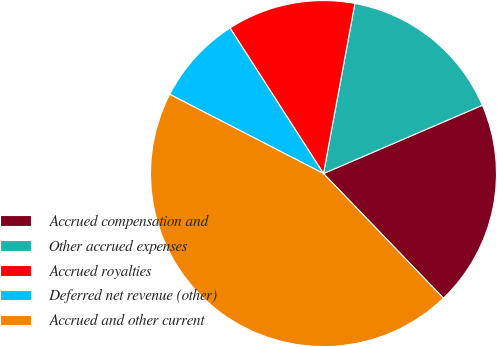Convert chart to OTSL. <chart><loc_0><loc_0><loc_500><loc_500><pie_chart><fcel>Accrued compensation and<fcel>Other accrued expenses<fcel>Accrued royalties<fcel>Deferred net revenue (other)<fcel>Accrued and other current<nl><fcel>19.27%<fcel>15.63%<fcel>11.99%<fcel>8.34%<fcel>44.77%<nl></chart> 